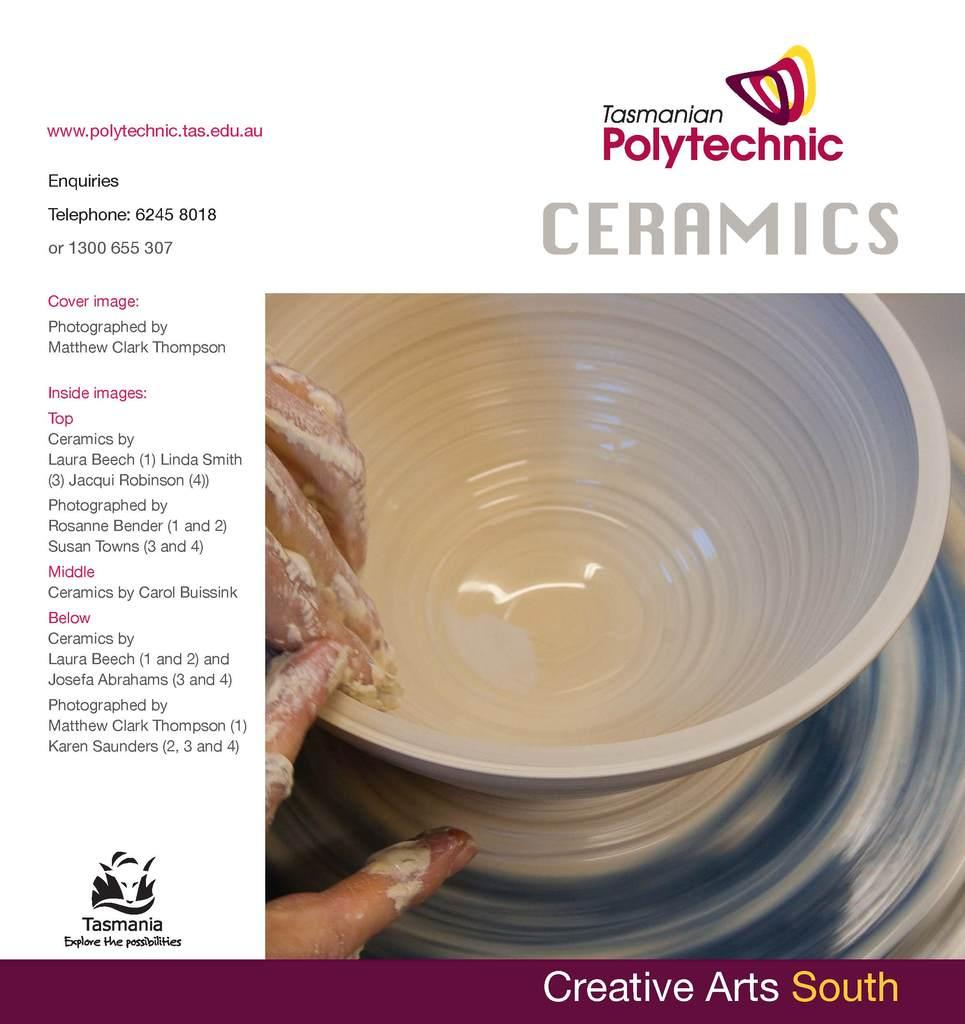What is featured in the image? There is a poster in the image. What is depicted in the poster? The poster contains a bowl and the hands of a person. Are there any written elements on the poster? Yes, there are texts on the poster. Are there any visual elements on the poster besides the bowl and hands? Yes, there are images on the poster. Can you tell me how many cans are shown in the image? There are no cans present in the image; it features a poster with a bowl, hands, texts, and images. 